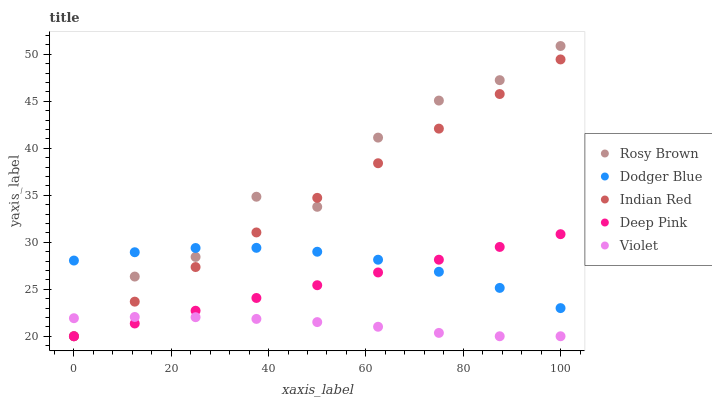Does Violet have the minimum area under the curve?
Answer yes or no. Yes. Does Rosy Brown have the maximum area under the curve?
Answer yes or no. Yes. Does Dodger Blue have the minimum area under the curve?
Answer yes or no. No. Does Dodger Blue have the maximum area under the curve?
Answer yes or no. No. Is Deep Pink the smoothest?
Answer yes or no. Yes. Is Rosy Brown the roughest?
Answer yes or no. Yes. Is Dodger Blue the smoothest?
Answer yes or no. No. Is Dodger Blue the roughest?
Answer yes or no. No. Does Violet have the lowest value?
Answer yes or no. Yes. Does Dodger Blue have the lowest value?
Answer yes or no. No. Does Rosy Brown have the highest value?
Answer yes or no. Yes. Does Dodger Blue have the highest value?
Answer yes or no. No. Is Violet less than Dodger Blue?
Answer yes or no. Yes. Is Dodger Blue greater than Violet?
Answer yes or no. Yes. Does Deep Pink intersect Dodger Blue?
Answer yes or no. Yes. Is Deep Pink less than Dodger Blue?
Answer yes or no. No. Is Deep Pink greater than Dodger Blue?
Answer yes or no. No. Does Violet intersect Dodger Blue?
Answer yes or no. No. 